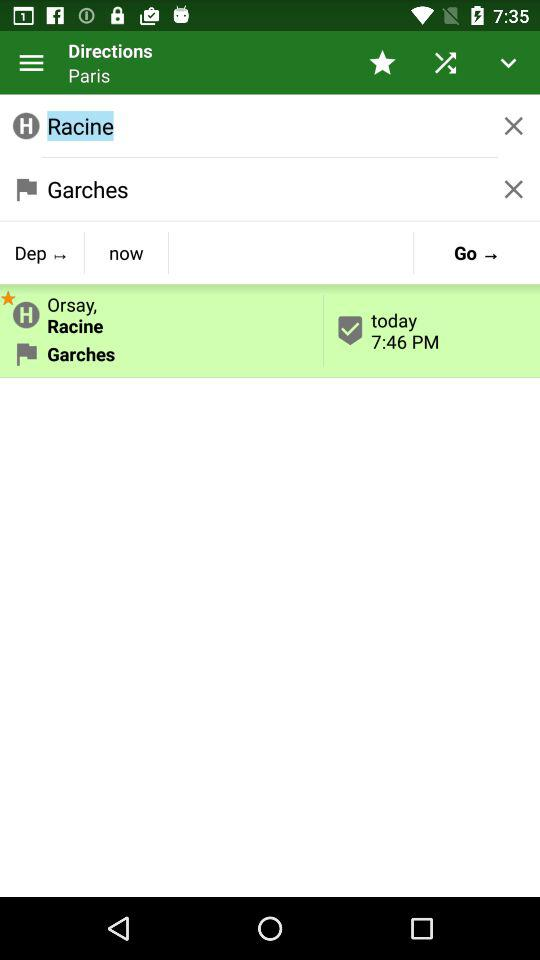What is the name of the source station? The name is "Garches". 